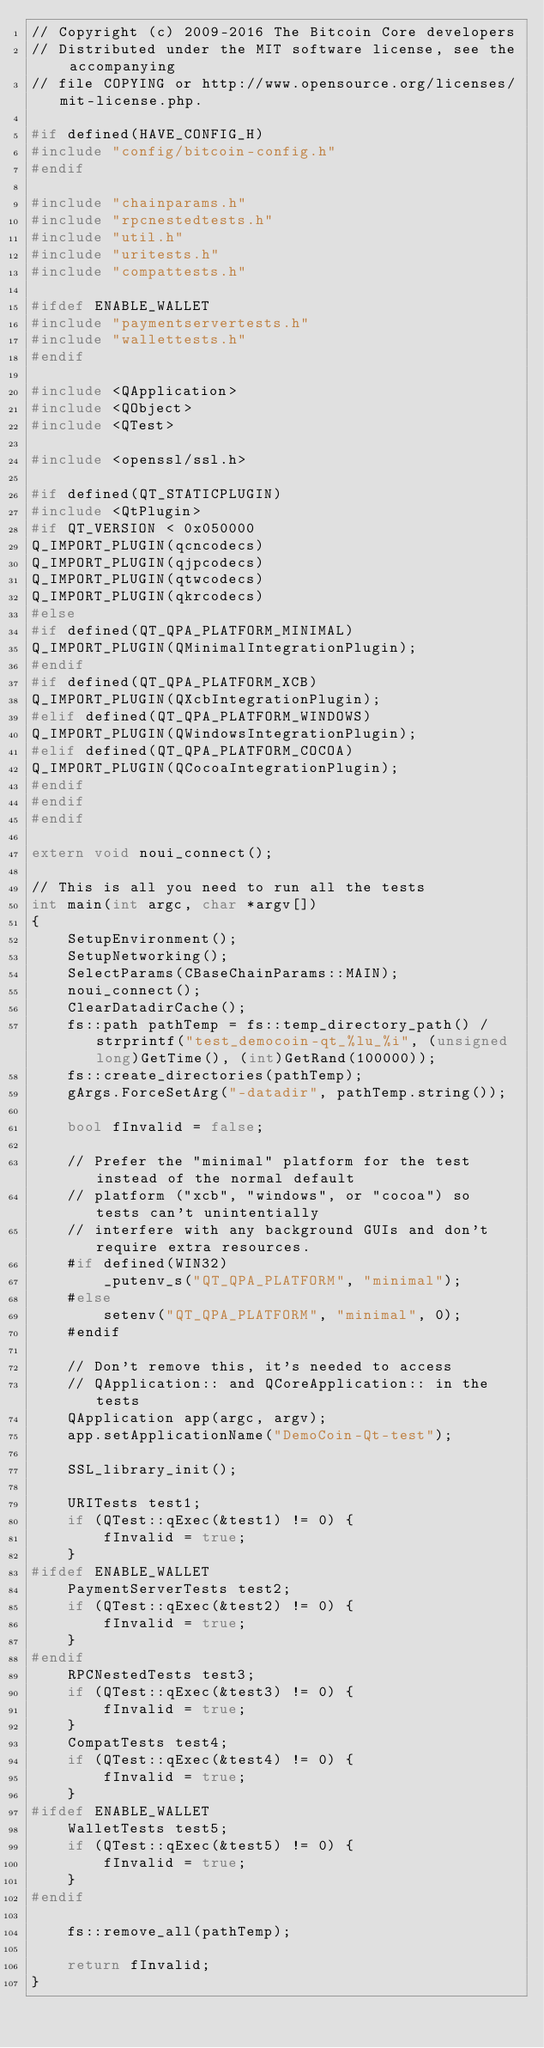Convert code to text. <code><loc_0><loc_0><loc_500><loc_500><_C++_>// Copyright (c) 2009-2016 The Bitcoin Core developers
// Distributed under the MIT software license, see the accompanying
// file COPYING or http://www.opensource.org/licenses/mit-license.php.

#if defined(HAVE_CONFIG_H)
#include "config/bitcoin-config.h"
#endif

#include "chainparams.h"
#include "rpcnestedtests.h"
#include "util.h"
#include "uritests.h"
#include "compattests.h"

#ifdef ENABLE_WALLET
#include "paymentservertests.h"
#include "wallettests.h"
#endif

#include <QApplication>
#include <QObject>
#include <QTest>

#include <openssl/ssl.h>

#if defined(QT_STATICPLUGIN)
#include <QtPlugin>
#if QT_VERSION < 0x050000
Q_IMPORT_PLUGIN(qcncodecs)
Q_IMPORT_PLUGIN(qjpcodecs)
Q_IMPORT_PLUGIN(qtwcodecs)
Q_IMPORT_PLUGIN(qkrcodecs)
#else
#if defined(QT_QPA_PLATFORM_MINIMAL)
Q_IMPORT_PLUGIN(QMinimalIntegrationPlugin);
#endif
#if defined(QT_QPA_PLATFORM_XCB)
Q_IMPORT_PLUGIN(QXcbIntegrationPlugin);
#elif defined(QT_QPA_PLATFORM_WINDOWS)
Q_IMPORT_PLUGIN(QWindowsIntegrationPlugin);
#elif defined(QT_QPA_PLATFORM_COCOA)
Q_IMPORT_PLUGIN(QCocoaIntegrationPlugin);
#endif
#endif
#endif

extern void noui_connect();

// This is all you need to run all the tests
int main(int argc, char *argv[])
{
    SetupEnvironment();
    SetupNetworking();
    SelectParams(CBaseChainParams::MAIN);
    noui_connect();
    ClearDatadirCache();
    fs::path pathTemp = fs::temp_directory_path() / strprintf("test_democoin-qt_%lu_%i", (unsigned long)GetTime(), (int)GetRand(100000));
    fs::create_directories(pathTemp);
    gArgs.ForceSetArg("-datadir", pathTemp.string());

    bool fInvalid = false;

    // Prefer the "minimal" platform for the test instead of the normal default
    // platform ("xcb", "windows", or "cocoa") so tests can't unintentially
    // interfere with any background GUIs and don't require extra resources.
    #if defined(WIN32)
        _putenv_s("QT_QPA_PLATFORM", "minimal");
    #else
        setenv("QT_QPA_PLATFORM", "minimal", 0);
    #endif

    // Don't remove this, it's needed to access
    // QApplication:: and QCoreApplication:: in the tests
    QApplication app(argc, argv);
    app.setApplicationName("DemoCoin-Qt-test");

    SSL_library_init();

    URITests test1;
    if (QTest::qExec(&test1) != 0) {
        fInvalid = true;
    }
#ifdef ENABLE_WALLET
    PaymentServerTests test2;
    if (QTest::qExec(&test2) != 0) {
        fInvalid = true;
    }
#endif
    RPCNestedTests test3;
    if (QTest::qExec(&test3) != 0) {
        fInvalid = true;
    }
    CompatTests test4;
    if (QTest::qExec(&test4) != 0) {
        fInvalid = true;
    }
#ifdef ENABLE_WALLET
    WalletTests test5;
    if (QTest::qExec(&test5) != 0) {
        fInvalid = true;
    }
#endif

    fs::remove_all(pathTemp);

    return fInvalid;
}
</code> 